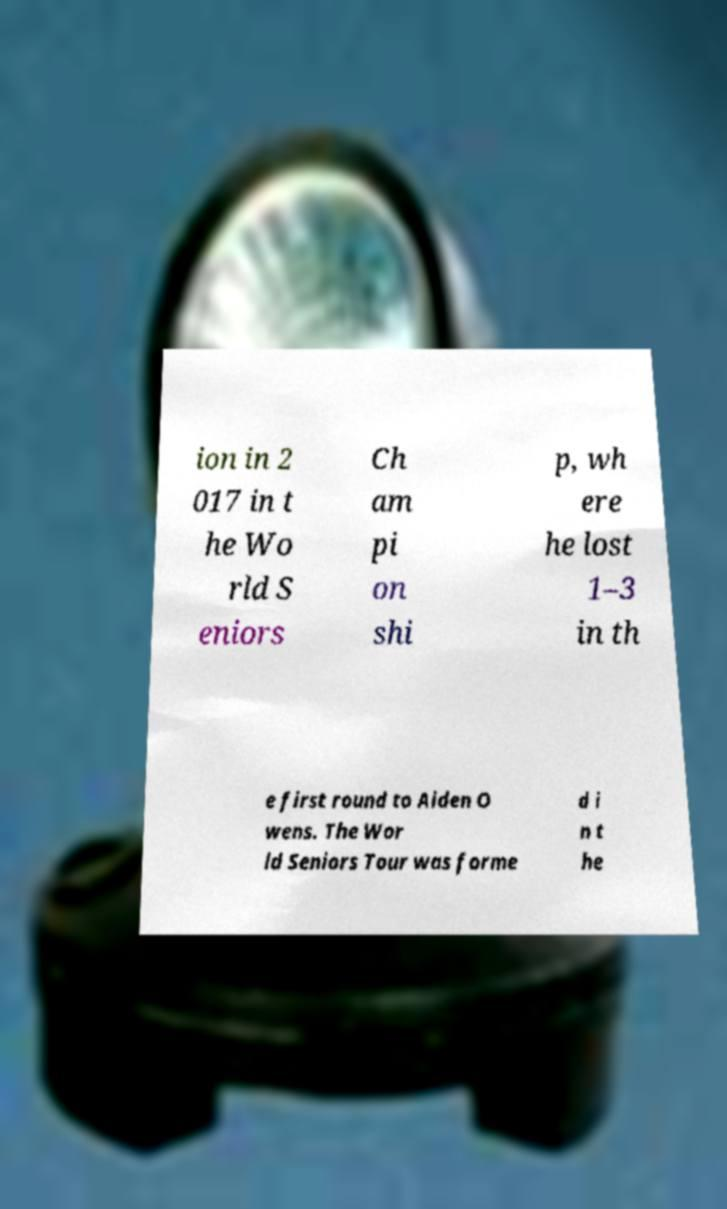Could you assist in decoding the text presented in this image and type it out clearly? ion in 2 017 in t he Wo rld S eniors Ch am pi on shi p, wh ere he lost 1–3 in th e first round to Aiden O wens. The Wor ld Seniors Tour was forme d i n t he 